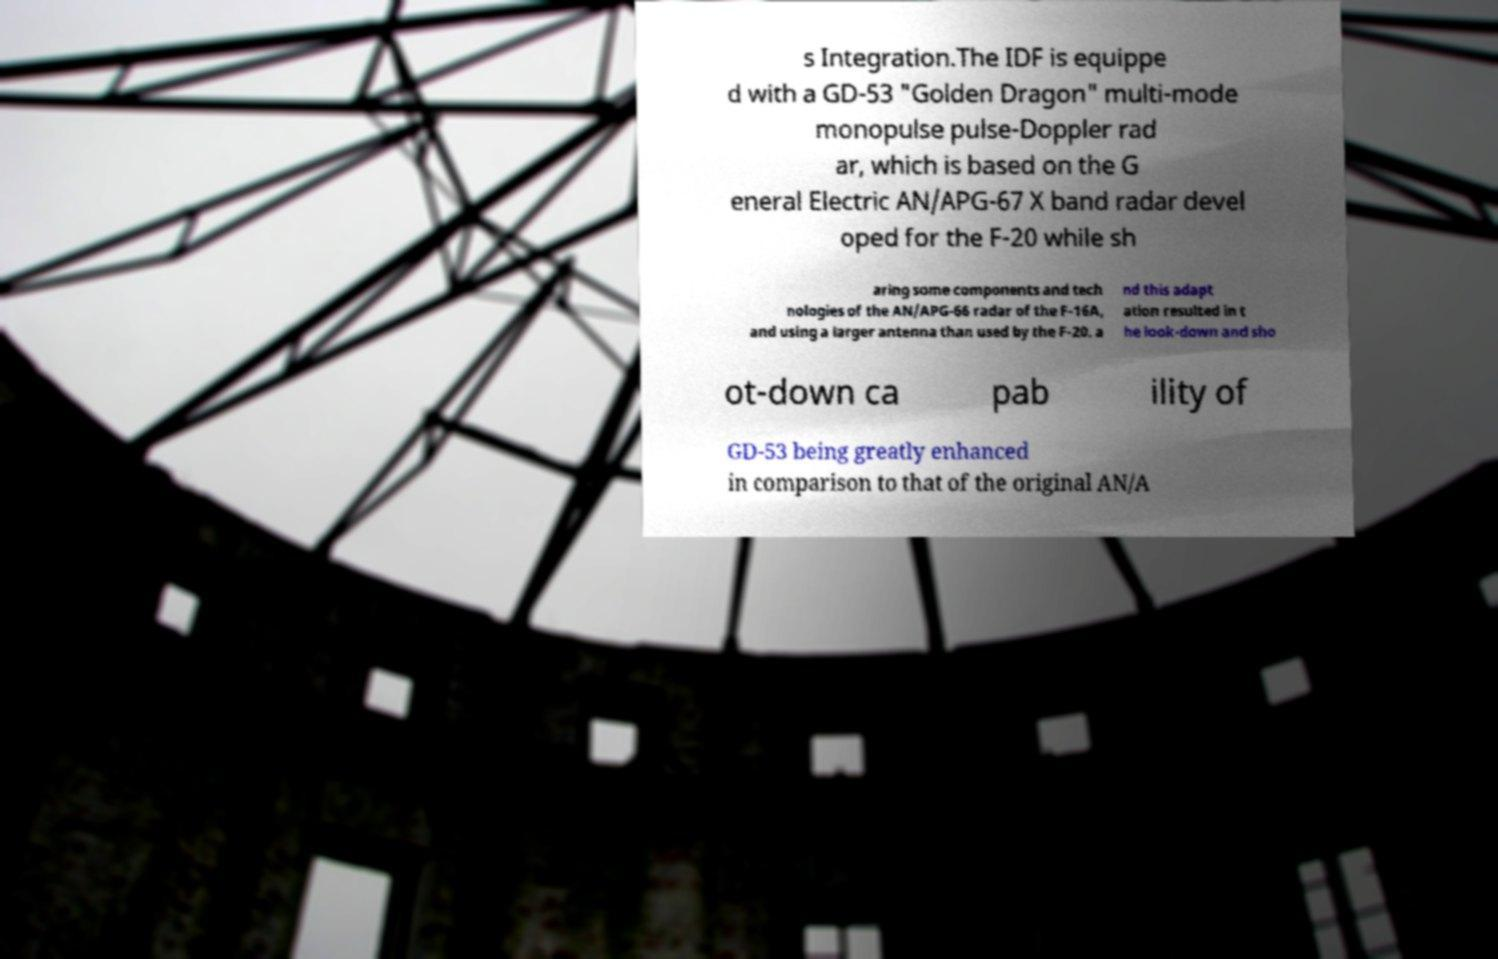Can you read and provide the text displayed in the image?This photo seems to have some interesting text. Can you extract and type it out for me? s Integration.The IDF is equippe d with a GD-53 "Golden Dragon" multi-mode monopulse pulse-Doppler rad ar, which is based on the G eneral Electric AN/APG-67 X band radar devel oped for the F-20 while sh aring some components and tech nologies of the AN/APG-66 radar of the F-16A, and using a larger antenna than used by the F-20. a nd this adapt ation resulted in t he look-down and sho ot-down ca pab ility of GD-53 being greatly enhanced in comparison to that of the original AN/A 